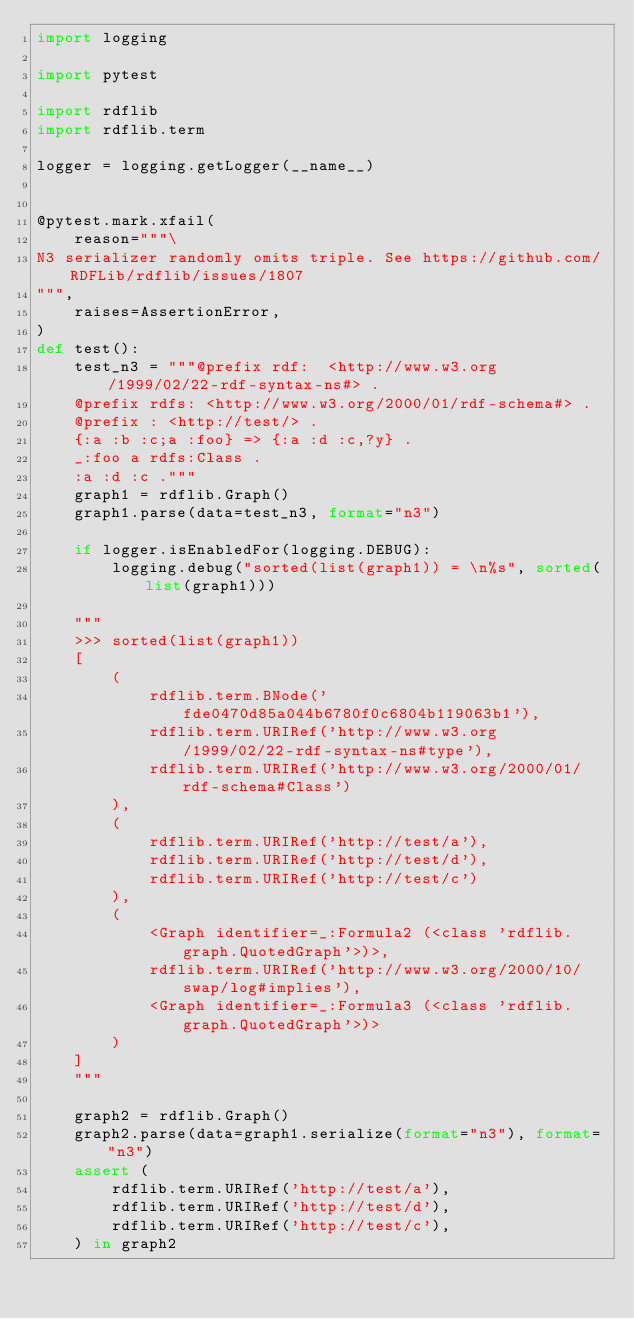Convert code to text. <code><loc_0><loc_0><loc_500><loc_500><_Python_>import logging

import pytest

import rdflib
import rdflib.term

logger = logging.getLogger(__name__)


@pytest.mark.xfail(
    reason="""\
N3 serializer randomly omits triple. See https://github.com/RDFLib/rdflib/issues/1807
""",
    raises=AssertionError,
)
def test():
    test_n3 = """@prefix rdf:  <http://www.w3.org/1999/02/22-rdf-syntax-ns#> .
    @prefix rdfs: <http://www.w3.org/2000/01/rdf-schema#> .
    @prefix : <http://test/> .
    {:a :b :c;a :foo} => {:a :d :c,?y} .
    _:foo a rdfs:Class .
    :a :d :c ."""
    graph1 = rdflib.Graph()
    graph1.parse(data=test_n3, format="n3")

    if logger.isEnabledFor(logging.DEBUG):
        logging.debug("sorted(list(graph1)) = \n%s", sorted(list(graph1)))

    """
    >>> sorted(list(graph1))
    [
        (
            rdflib.term.BNode('fde0470d85a044b6780f0c6804b119063b1'),
            rdflib.term.URIRef('http://www.w3.org/1999/02/22-rdf-syntax-ns#type'),
            rdflib.term.URIRef('http://www.w3.org/2000/01/rdf-schema#Class')
        ),
        (
            rdflib.term.URIRef('http://test/a'),
            rdflib.term.URIRef('http://test/d'),
            rdflib.term.URIRef('http://test/c')
        ),
        (
            <Graph identifier=_:Formula2 (<class 'rdflib.graph.QuotedGraph'>)>,
            rdflib.term.URIRef('http://www.w3.org/2000/10/swap/log#implies'),
            <Graph identifier=_:Formula3 (<class 'rdflib.graph.QuotedGraph'>)>
        )
    ]
    """

    graph2 = rdflib.Graph()
    graph2.parse(data=graph1.serialize(format="n3"), format="n3")
    assert (
        rdflib.term.URIRef('http://test/a'),
        rdflib.term.URIRef('http://test/d'),
        rdflib.term.URIRef('http://test/c'),
    ) in graph2
</code> 